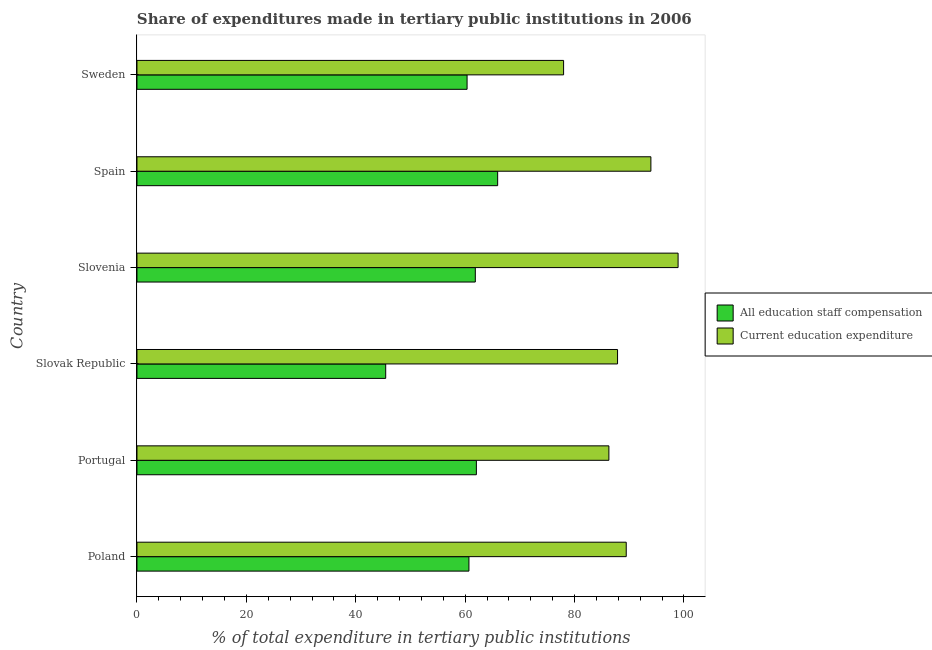How many different coloured bars are there?
Offer a terse response. 2. How many groups of bars are there?
Keep it short and to the point. 6. Are the number of bars per tick equal to the number of legend labels?
Keep it short and to the point. Yes. Are the number of bars on each tick of the Y-axis equal?
Offer a terse response. Yes. What is the expenditure in education in Spain?
Offer a terse response. 93.95. Across all countries, what is the maximum expenditure in staff compensation?
Provide a succinct answer. 65.94. Across all countries, what is the minimum expenditure in staff compensation?
Ensure brevity in your answer.  45.47. In which country was the expenditure in staff compensation maximum?
Your response must be concise. Spain. In which country was the expenditure in education minimum?
Offer a very short reply. Sweden. What is the total expenditure in education in the graph?
Make the answer very short. 534.45. What is the difference between the expenditure in staff compensation in Slovak Republic and that in Slovenia?
Your response must be concise. -16.38. What is the difference between the expenditure in education in Slovak Republic and the expenditure in staff compensation in Slovenia?
Give a very brief answer. 26. What is the average expenditure in education per country?
Provide a succinct answer. 89.08. What is the difference between the expenditure in education and expenditure in staff compensation in Slovenia?
Give a very brief answer. 37.07. In how many countries, is the expenditure in education greater than 80 %?
Provide a short and direct response. 5. What is the ratio of the expenditure in staff compensation in Slovak Republic to that in Sweden?
Your answer should be very brief. 0.75. Is the expenditure in education in Slovenia less than that in Spain?
Make the answer very short. No. Is the difference between the expenditure in education in Portugal and Slovenia greater than the difference between the expenditure in staff compensation in Portugal and Slovenia?
Provide a short and direct response. No. What is the difference between the highest and the second highest expenditure in education?
Provide a succinct answer. 4.97. What is the difference between the highest and the lowest expenditure in staff compensation?
Your answer should be very brief. 20.46. In how many countries, is the expenditure in education greater than the average expenditure in education taken over all countries?
Your answer should be compact. 3. What does the 2nd bar from the top in Sweden represents?
Your answer should be very brief. All education staff compensation. What does the 2nd bar from the bottom in Slovak Republic represents?
Your response must be concise. Current education expenditure. How many bars are there?
Make the answer very short. 12. Are the values on the major ticks of X-axis written in scientific E-notation?
Offer a terse response. No. Does the graph contain any zero values?
Your answer should be very brief. No. How many legend labels are there?
Provide a succinct answer. 2. How are the legend labels stacked?
Provide a succinct answer. Vertical. What is the title of the graph?
Provide a short and direct response. Share of expenditures made in tertiary public institutions in 2006. Does "Rural" appear as one of the legend labels in the graph?
Provide a short and direct response. No. What is the label or title of the X-axis?
Make the answer very short. % of total expenditure in tertiary public institutions. What is the % of total expenditure in tertiary public institutions in All education staff compensation in Poland?
Provide a succinct answer. 60.69. What is the % of total expenditure in tertiary public institutions of Current education expenditure in Poland?
Give a very brief answer. 89.45. What is the % of total expenditure in tertiary public institutions of All education staff compensation in Portugal?
Give a very brief answer. 62.05. What is the % of total expenditure in tertiary public institutions in Current education expenditure in Portugal?
Give a very brief answer. 86.28. What is the % of total expenditure in tertiary public institutions of All education staff compensation in Slovak Republic?
Offer a very short reply. 45.47. What is the % of total expenditure in tertiary public institutions of Current education expenditure in Slovak Republic?
Keep it short and to the point. 87.86. What is the % of total expenditure in tertiary public institutions in All education staff compensation in Slovenia?
Provide a short and direct response. 61.85. What is the % of total expenditure in tertiary public institutions of Current education expenditure in Slovenia?
Keep it short and to the point. 98.93. What is the % of total expenditure in tertiary public institutions in All education staff compensation in Spain?
Offer a terse response. 65.94. What is the % of total expenditure in tertiary public institutions of Current education expenditure in Spain?
Offer a terse response. 93.95. What is the % of total expenditure in tertiary public institutions in All education staff compensation in Sweden?
Make the answer very short. 60.35. What is the % of total expenditure in tertiary public institutions in Current education expenditure in Sweden?
Offer a terse response. 77.99. Across all countries, what is the maximum % of total expenditure in tertiary public institutions in All education staff compensation?
Ensure brevity in your answer.  65.94. Across all countries, what is the maximum % of total expenditure in tertiary public institutions of Current education expenditure?
Your response must be concise. 98.93. Across all countries, what is the minimum % of total expenditure in tertiary public institutions in All education staff compensation?
Your response must be concise. 45.47. Across all countries, what is the minimum % of total expenditure in tertiary public institutions of Current education expenditure?
Offer a very short reply. 77.99. What is the total % of total expenditure in tertiary public institutions of All education staff compensation in the graph?
Your response must be concise. 356.36. What is the total % of total expenditure in tertiary public institutions of Current education expenditure in the graph?
Your response must be concise. 534.45. What is the difference between the % of total expenditure in tertiary public institutions in All education staff compensation in Poland and that in Portugal?
Your response must be concise. -1.36. What is the difference between the % of total expenditure in tertiary public institutions of Current education expenditure in Poland and that in Portugal?
Your response must be concise. 3.17. What is the difference between the % of total expenditure in tertiary public institutions of All education staff compensation in Poland and that in Slovak Republic?
Ensure brevity in your answer.  15.22. What is the difference between the % of total expenditure in tertiary public institutions in Current education expenditure in Poland and that in Slovak Republic?
Offer a terse response. 1.59. What is the difference between the % of total expenditure in tertiary public institutions of All education staff compensation in Poland and that in Slovenia?
Give a very brief answer. -1.16. What is the difference between the % of total expenditure in tertiary public institutions of Current education expenditure in Poland and that in Slovenia?
Your response must be concise. -9.48. What is the difference between the % of total expenditure in tertiary public institutions of All education staff compensation in Poland and that in Spain?
Offer a terse response. -5.25. What is the difference between the % of total expenditure in tertiary public institutions in Current education expenditure in Poland and that in Spain?
Make the answer very short. -4.51. What is the difference between the % of total expenditure in tertiary public institutions in All education staff compensation in Poland and that in Sweden?
Give a very brief answer. 0.34. What is the difference between the % of total expenditure in tertiary public institutions of Current education expenditure in Poland and that in Sweden?
Keep it short and to the point. 11.45. What is the difference between the % of total expenditure in tertiary public institutions in All education staff compensation in Portugal and that in Slovak Republic?
Offer a terse response. 16.58. What is the difference between the % of total expenditure in tertiary public institutions in Current education expenditure in Portugal and that in Slovak Republic?
Give a very brief answer. -1.58. What is the difference between the % of total expenditure in tertiary public institutions of All education staff compensation in Portugal and that in Slovenia?
Your answer should be compact. 0.2. What is the difference between the % of total expenditure in tertiary public institutions in Current education expenditure in Portugal and that in Slovenia?
Make the answer very short. -12.65. What is the difference between the % of total expenditure in tertiary public institutions in All education staff compensation in Portugal and that in Spain?
Make the answer very short. -3.89. What is the difference between the % of total expenditure in tertiary public institutions in Current education expenditure in Portugal and that in Spain?
Your response must be concise. -7.68. What is the difference between the % of total expenditure in tertiary public institutions of All education staff compensation in Portugal and that in Sweden?
Provide a succinct answer. 1.7. What is the difference between the % of total expenditure in tertiary public institutions in Current education expenditure in Portugal and that in Sweden?
Your response must be concise. 8.28. What is the difference between the % of total expenditure in tertiary public institutions of All education staff compensation in Slovak Republic and that in Slovenia?
Offer a terse response. -16.38. What is the difference between the % of total expenditure in tertiary public institutions of Current education expenditure in Slovak Republic and that in Slovenia?
Your answer should be very brief. -11.07. What is the difference between the % of total expenditure in tertiary public institutions of All education staff compensation in Slovak Republic and that in Spain?
Ensure brevity in your answer.  -20.46. What is the difference between the % of total expenditure in tertiary public institutions of Current education expenditure in Slovak Republic and that in Spain?
Offer a terse response. -6.1. What is the difference between the % of total expenditure in tertiary public institutions of All education staff compensation in Slovak Republic and that in Sweden?
Give a very brief answer. -14.88. What is the difference between the % of total expenditure in tertiary public institutions in Current education expenditure in Slovak Republic and that in Sweden?
Give a very brief answer. 9.86. What is the difference between the % of total expenditure in tertiary public institutions in All education staff compensation in Slovenia and that in Spain?
Provide a succinct answer. -4.08. What is the difference between the % of total expenditure in tertiary public institutions in Current education expenditure in Slovenia and that in Spain?
Ensure brevity in your answer.  4.97. What is the difference between the % of total expenditure in tertiary public institutions in All education staff compensation in Slovenia and that in Sweden?
Provide a succinct answer. 1.5. What is the difference between the % of total expenditure in tertiary public institutions in Current education expenditure in Slovenia and that in Sweden?
Offer a terse response. 20.93. What is the difference between the % of total expenditure in tertiary public institutions of All education staff compensation in Spain and that in Sweden?
Give a very brief answer. 5.59. What is the difference between the % of total expenditure in tertiary public institutions in Current education expenditure in Spain and that in Sweden?
Your response must be concise. 15.96. What is the difference between the % of total expenditure in tertiary public institutions of All education staff compensation in Poland and the % of total expenditure in tertiary public institutions of Current education expenditure in Portugal?
Ensure brevity in your answer.  -25.59. What is the difference between the % of total expenditure in tertiary public institutions in All education staff compensation in Poland and the % of total expenditure in tertiary public institutions in Current education expenditure in Slovak Republic?
Offer a very short reply. -27.17. What is the difference between the % of total expenditure in tertiary public institutions of All education staff compensation in Poland and the % of total expenditure in tertiary public institutions of Current education expenditure in Slovenia?
Your answer should be compact. -38.24. What is the difference between the % of total expenditure in tertiary public institutions in All education staff compensation in Poland and the % of total expenditure in tertiary public institutions in Current education expenditure in Spain?
Provide a succinct answer. -33.26. What is the difference between the % of total expenditure in tertiary public institutions of All education staff compensation in Poland and the % of total expenditure in tertiary public institutions of Current education expenditure in Sweden?
Your answer should be very brief. -17.3. What is the difference between the % of total expenditure in tertiary public institutions in All education staff compensation in Portugal and the % of total expenditure in tertiary public institutions in Current education expenditure in Slovak Republic?
Ensure brevity in your answer.  -25.81. What is the difference between the % of total expenditure in tertiary public institutions of All education staff compensation in Portugal and the % of total expenditure in tertiary public institutions of Current education expenditure in Slovenia?
Make the answer very short. -36.88. What is the difference between the % of total expenditure in tertiary public institutions in All education staff compensation in Portugal and the % of total expenditure in tertiary public institutions in Current education expenditure in Spain?
Ensure brevity in your answer.  -31.9. What is the difference between the % of total expenditure in tertiary public institutions of All education staff compensation in Portugal and the % of total expenditure in tertiary public institutions of Current education expenditure in Sweden?
Provide a succinct answer. -15.94. What is the difference between the % of total expenditure in tertiary public institutions in All education staff compensation in Slovak Republic and the % of total expenditure in tertiary public institutions in Current education expenditure in Slovenia?
Your answer should be compact. -53.45. What is the difference between the % of total expenditure in tertiary public institutions in All education staff compensation in Slovak Republic and the % of total expenditure in tertiary public institutions in Current education expenditure in Spain?
Make the answer very short. -48.48. What is the difference between the % of total expenditure in tertiary public institutions in All education staff compensation in Slovak Republic and the % of total expenditure in tertiary public institutions in Current education expenditure in Sweden?
Your answer should be compact. -32.52. What is the difference between the % of total expenditure in tertiary public institutions in All education staff compensation in Slovenia and the % of total expenditure in tertiary public institutions in Current education expenditure in Spain?
Ensure brevity in your answer.  -32.1. What is the difference between the % of total expenditure in tertiary public institutions of All education staff compensation in Slovenia and the % of total expenditure in tertiary public institutions of Current education expenditure in Sweden?
Offer a terse response. -16.14. What is the difference between the % of total expenditure in tertiary public institutions in All education staff compensation in Spain and the % of total expenditure in tertiary public institutions in Current education expenditure in Sweden?
Provide a short and direct response. -12.06. What is the average % of total expenditure in tertiary public institutions in All education staff compensation per country?
Keep it short and to the point. 59.39. What is the average % of total expenditure in tertiary public institutions in Current education expenditure per country?
Ensure brevity in your answer.  89.08. What is the difference between the % of total expenditure in tertiary public institutions of All education staff compensation and % of total expenditure in tertiary public institutions of Current education expenditure in Poland?
Ensure brevity in your answer.  -28.76. What is the difference between the % of total expenditure in tertiary public institutions in All education staff compensation and % of total expenditure in tertiary public institutions in Current education expenditure in Portugal?
Give a very brief answer. -24.22. What is the difference between the % of total expenditure in tertiary public institutions of All education staff compensation and % of total expenditure in tertiary public institutions of Current education expenditure in Slovak Republic?
Make the answer very short. -42.38. What is the difference between the % of total expenditure in tertiary public institutions in All education staff compensation and % of total expenditure in tertiary public institutions in Current education expenditure in Slovenia?
Give a very brief answer. -37.07. What is the difference between the % of total expenditure in tertiary public institutions in All education staff compensation and % of total expenditure in tertiary public institutions in Current education expenditure in Spain?
Your answer should be very brief. -28.02. What is the difference between the % of total expenditure in tertiary public institutions of All education staff compensation and % of total expenditure in tertiary public institutions of Current education expenditure in Sweden?
Keep it short and to the point. -17.64. What is the ratio of the % of total expenditure in tertiary public institutions in All education staff compensation in Poland to that in Portugal?
Offer a very short reply. 0.98. What is the ratio of the % of total expenditure in tertiary public institutions of Current education expenditure in Poland to that in Portugal?
Offer a very short reply. 1.04. What is the ratio of the % of total expenditure in tertiary public institutions in All education staff compensation in Poland to that in Slovak Republic?
Your answer should be compact. 1.33. What is the ratio of the % of total expenditure in tertiary public institutions of Current education expenditure in Poland to that in Slovak Republic?
Your response must be concise. 1.02. What is the ratio of the % of total expenditure in tertiary public institutions of All education staff compensation in Poland to that in Slovenia?
Your answer should be compact. 0.98. What is the ratio of the % of total expenditure in tertiary public institutions in Current education expenditure in Poland to that in Slovenia?
Give a very brief answer. 0.9. What is the ratio of the % of total expenditure in tertiary public institutions of All education staff compensation in Poland to that in Spain?
Offer a very short reply. 0.92. What is the ratio of the % of total expenditure in tertiary public institutions in Current education expenditure in Poland to that in Spain?
Make the answer very short. 0.95. What is the ratio of the % of total expenditure in tertiary public institutions of All education staff compensation in Poland to that in Sweden?
Give a very brief answer. 1.01. What is the ratio of the % of total expenditure in tertiary public institutions of Current education expenditure in Poland to that in Sweden?
Provide a short and direct response. 1.15. What is the ratio of the % of total expenditure in tertiary public institutions in All education staff compensation in Portugal to that in Slovak Republic?
Keep it short and to the point. 1.36. What is the ratio of the % of total expenditure in tertiary public institutions in Current education expenditure in Portugal to that in Slovak Republic?
Your response must be concise. 0.98. What is the ratio of the % of total expenditure in tertiary public institutions of All education staff compensation in Portugal to that in Slovenia?
Provide a short and direct response. 1. What is the ratio of the % of total expenditure in tertiary public institutions of Current education expenditure in Portugal to that in Slovenia?
Give a very brief answer. 0.87. What is the ratio of the % of total expenditure in tertiary public institutions of All education staff compensation in Portugal to that in Spain?
Offer a terse response. 0.94. What is the ratio of the % of total expenditure in tertiary public institutions in Current education expenditure in Portugal to that in Spain?
Ensure brevity in your answer.  0.92. What is the ratio of the % of total expenditure in tertiary public institutions in All education staff compensation in Portugal to that in Sweden?
Provide a short and direct response. 1.03. What is the ratio of the % of total expenditure in tertiary public institutions of Current education expenditure in Portugal to that in Sweden?
Ensure brevity in your answer.  1.11. What is the ratio of the % of total expenditure in tertiary public institutions in All education staff compensation in Slovak Republic to that in Slovenia?
Keep it short and to the point. 0.74. What is the ratio of the % of total expenditure in tertiary public institutions of Current education expenditure in Slovak Republic to that in Slovenia?
Offer a terse response. 0.89. What is the ratio of the % of total expenditure in tertiary public institutions of All education staff compensation in Slovak Republic to that in Spain?
Your answer should be very brief. 0.69. What is the ratio of the % of total expenditure in tertiary public institutions of Current education expenditure in Slovak Republic to that in Spain?
Give a very brief answer. 0.94. What is the ratio of the % of total expenditure in tertiary public institutions in All education staff compensation in Slovak Republic to that in Sweden?
Provide a short and direct response. 0.75. What is the ratio of the % of total expenditure in tertiary public institutions of Current education expenditure in Slovak Republic to that in Sweden?
Your answer should be compact. 1.13. What is the ratio of the % of total expenditure in tertiary public institutions in All education staff compensation in Slovenia to that in Spain?
Provide a short and direct response. 0.94. What is the ratio of the % of total expenditure in tertiary public institutions in Current education expenditure in Slovenia to that in Spain?
Provide a short and direct response. 1.05. What is the ratio of the % of total expenditure in tertiary public institutions in All education staff compensation in Slovenia to that in Sweden?
Make the answer very short. 1.02. What is the ratio of the % of total expenditure in tertiary public institutions of Current education expenditure in Slovenia to that in Sweden?
Offer a very short reply. 1.27. What is the ratio of the % of total expenditure in tertiary public institutions of All education staff compensation in Spain to that in Sweden?
Your answer should be very brief. 1.09. What is the ratio of the % of total expenditure in tertiary public institutions of Current education expenditure in Spain to that in Sweden?
Provide a succinct answer. 1.2. What is the difference between the highest and the second highest % of total expenditure in tertiary public institutions of All education staff compensation?
Offer a terse response. 3.89. What is the difference between the highest and the second highest % of total expenditure in tertiary public institutions of Current education expenditure?
Offer a terse response. 4.97. What is the difference between the highest and the lowest % of total expenditure in tertiary public institutions of All education staff compensation?
Your answer should be very brief. 20.46. What is the difference between the highest and the lowest % of total expenditure in tertiary public institutions of Current education expenditure?
Make the answer very short. 20.93. 